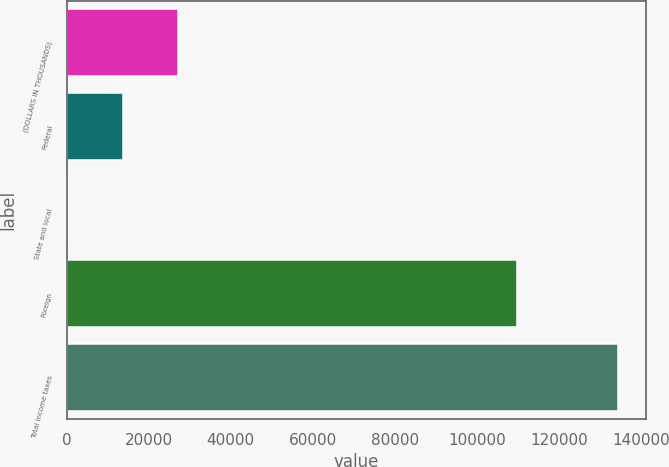Convert chart. <chart><loc_0><loc_0><loc_500><loc_500><bar_chart><fcel>(DOLLARS IN THOUSANDS)<fcel>Federal<fcel>State and local<fcel>Foreign<fcel>Total income taxes<nl><fcel>27114.8<fcel>13689.4<fcel>264<fcel>109729<fcel>134518<nl></chart> 